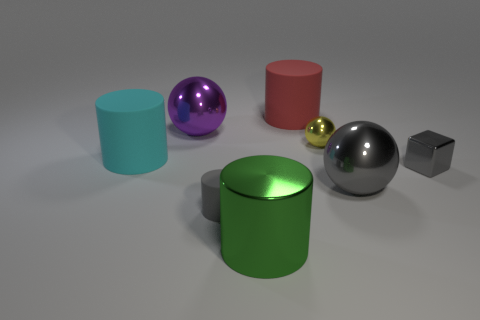Is there a big thing that has the same shape as the tiny yellow metallic object?
Offer a terse response. Yes. The metal cube that is the same size as the yellow thing is what color?
Ensure brevity in your answer.  Gray. What is the color of the object that is behind the large shiny sphere behind the big gray shiny ball?
Give a very brief answer. Red. There is a large object that is on the right side of the yellow metal ball; does it have the same color as the tiny matte object?
Give a very brief answer. Yes. What is the shape of the small gray object right of the metal thing in front of the big sphere that is in front of the big purple shiny sphere?
Offer a terse response. Cube. There is a big shiny thing on the left side of the big shiny cylinder; how many things are in front of it?
Your response must be concise. 6. Does the big red cylinder have the same material as the small gray cylinder?
Keep it short and to the point. Yes. What number of matte objects are to the right of the big metallic ball left of the cylinder that is on the right side of the large green thing?
Your response must be concise. 2. The ball in front of the tiny gray cube is what color?
Provide a short and direct response. Gray. What shape is the large metallic thing on the right side of the cylinder behind the big purple shiny object?
Provide a succinct answer. Sphere. 